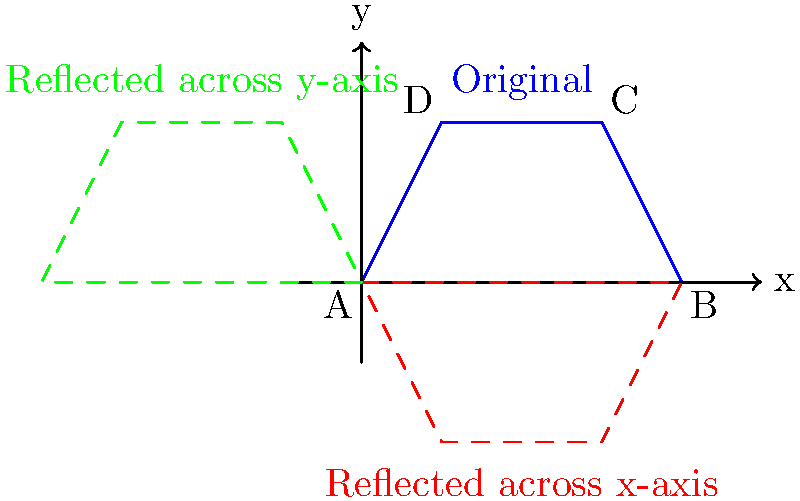The wing shape of a classic World War II fighter plane is represented by the blue quadrilateral ABCD in the coordinate plane. If this wing shape is reflected across both the x-axis and y-axis, what will be the coordinates of point C after both reflections? Let's approach this step-by-step:

1) First, we need to identify the original coordinates of point C. From the diagram, we can see that C is at (3,2).

2) Reflection across the x-axis:
   - This reflection changes the sign of the y-coordinate.
   - After this reflection, C would be at (3,-2).

3) Reflection across the y-axis:
   - This reflection changes the sign of the x-coordinate.
   - Starting from (3,-2), after this reflection, C would be at (-3,-2).

4) The order of reflections doesn't matter in this case, as we're reflecting across both axes. If we had reflected across the y-axis first and then the x-axis, we would still end up at (-3,-2).

5) Therefore, after both reflections, point C will be at coordinates (-3,-2).

This transformation effectively rotates the wing shape by 180° around the origin, which is an interesting property of double reflection across perpendicular axes.
Answer: $(-3,-2)$ 